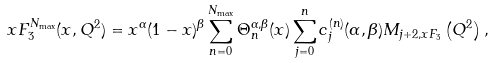<formula> <loc_0><loc_0><loc_500><loc_500>x F _ { 3 } ^ { N _ { \max } } ( x , Q ^ { 2 } ) = x ^ { \alpha } ( 1 - x ) ^ { \beta } \sum _ { n = 0 } ^ { N _ { \max } } \Theta _ { n } ^ { \alpha , \beta } ( x ) \sum _ { j = 0 } ^ { n } c _ { j } ^ { ( n ) } { ( \alpha , \beta ) } M _ { j + 2 , x F _ { 3 } } \left ( Q ^ { 2 } \right ) ,</formula> 